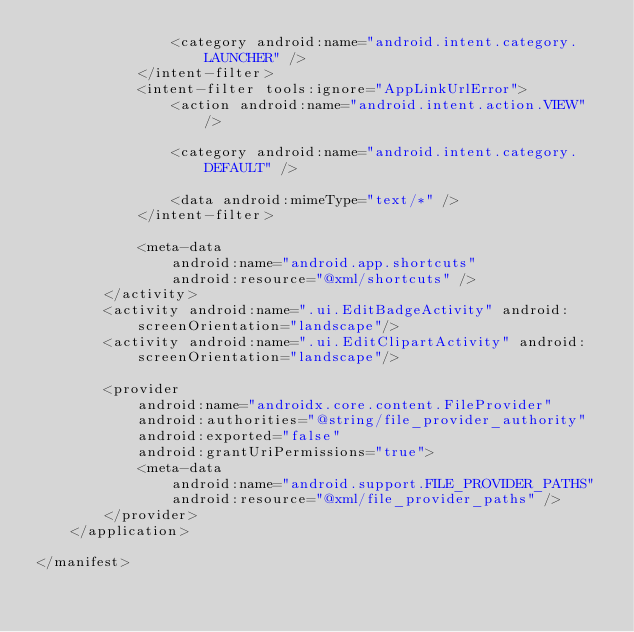<code> <loc_0><loc_0><loc_500><loc_500><_XML_>                <category android:name="android.intent.category.LAUNCHER" />
            </intent-filter>
            <intent-filter tools:ignore="AppLinkUrlError">
                <action android:name="android.intent.action.VIEW" />

                <category android:name="android.intent.category.DEFAULT" />

                <data android:mimeType="text/*" />
            </intent-filter>

            <meta-data
                android:name="android.app.shortcuts"
                android:resource="@xml/shortcuts" />
        </activity>
        <activity android:name=".ui.EditBadgeActivity" android:screenOrientation="landscape"/>
        <activity android:name=".ui.EditClipartActivity" android:screenOrientation="landscape"/>

        <provider
            android:name="androidx.core.content.FileProvider"
            android:authorities="@string/file_provider_authority"
            android:exported="false"
            android:grantUriPermissions="true">
            <meta-data
                android:name="android.support.FILE_PROVIDER_PATHS"
                android:resource="@xml/file_provider_paths" />
        </provider>
    </application>

</manifest></code> 